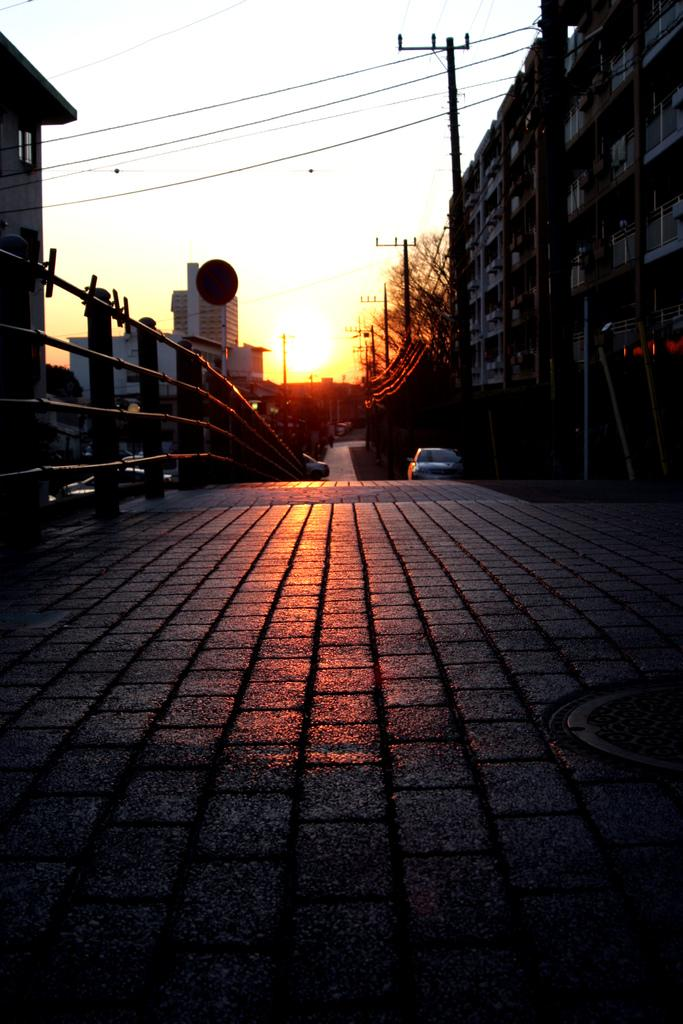What type of vehicle is on the road in the image? There is a car on the road in the image. What else can be seen in the image besides the car? Buildings, trees, poles, and the sky are visible in the image. Can you describe the buildings in the image? The buildings in the image are tall structures with windows and doors. What is the color of the sky in the background of the image? The sky is visible in the background of the image, but the color is not mentioned in the facts. What type of guitar is the grandmother playing in the image? There is no guitar or grandmother present in the image. 